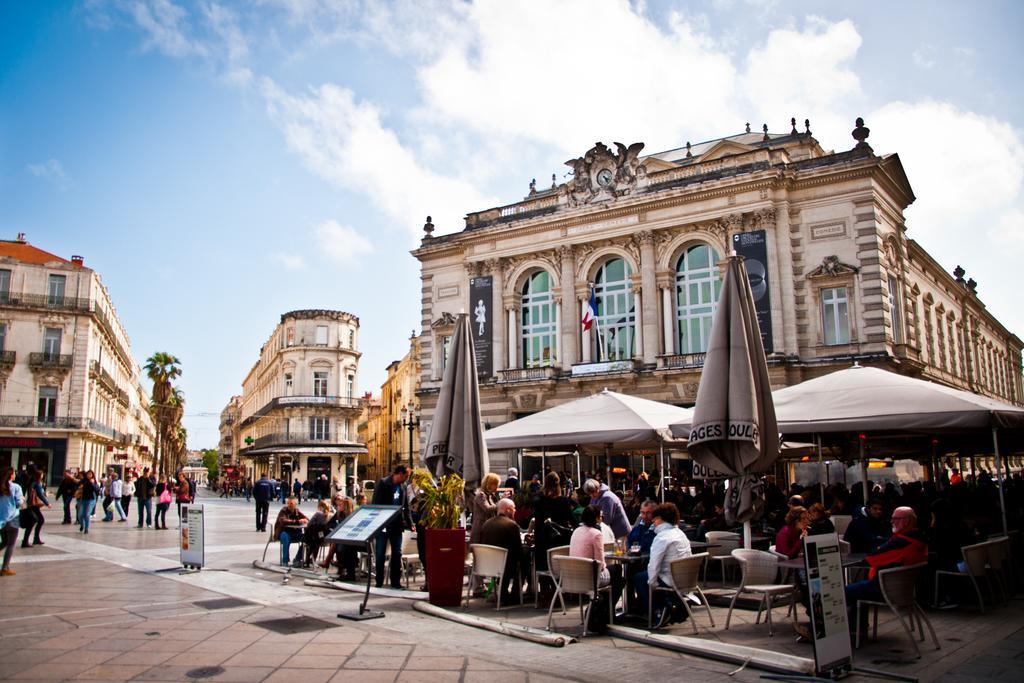In one or two sentences, can you explain what this image depicts? In this image we can see few persons are sitting on the chairs at the tables and few persons are standing. There are tents, umbrellas, boards, plants and objects. In the background we can see buildings, windows, trees, flagpoles, few persons are walking and clouds in the sky. 